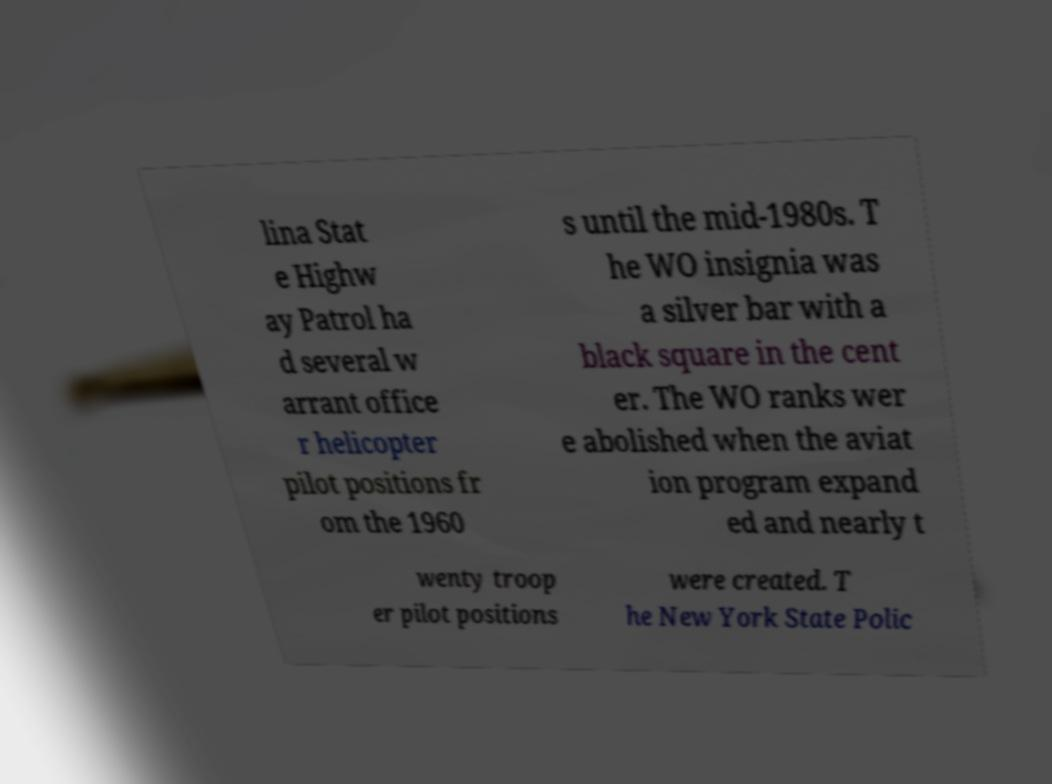Could you extract and type out the text from this image? lina Stat e Highw ay Patrol ha d several w arrant office r helicopter pilot positions fr om the 1960 s until the mid-1980s. T he WO insignia was a silver bar with a black square in the cent er. The WO ranks wer e abolished when the aviat ion program expand ed and nearly t wenty troop er pilot positions were created. T he New York State Polic 